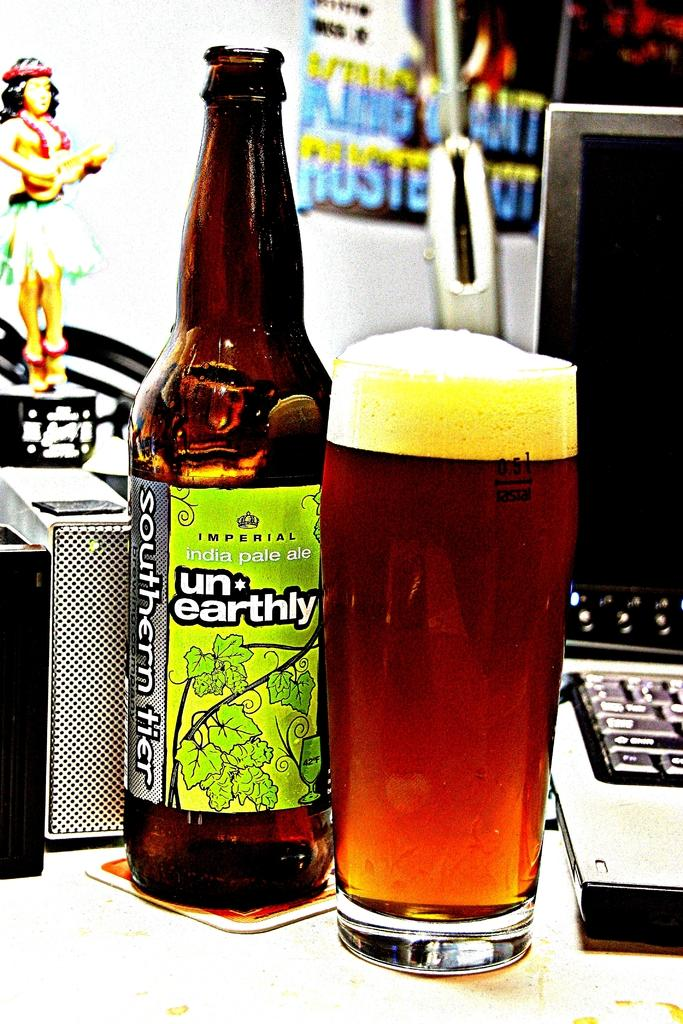What objects are on the table in the image? There is a bottle, a glass, a matchbox, a laptop, and a toy on the table in the image. What can be found in the background of the image? There is a poster in the background. What might be used for lighting a fire in the image? The matchbox on the table might be used for lighting a fire. What type of electronic device is on the table? There is a laptop on the table. What type of stocking is hanging from the laptop in the image? There is no stocking hanging from the laptop in the image. What form does the stem of the toy take in the image? There is no stem present in the image, as the toy does not have a stem. 